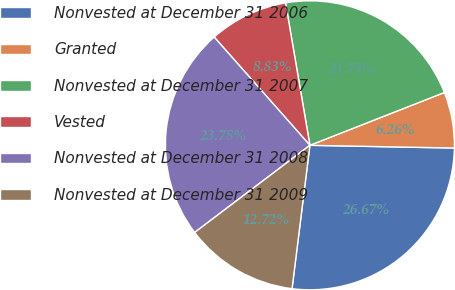<chart> <loc_0><loc_0><loc_500><loc_500><pie_chart><fcel>Nonvested at December 31 2006<fcel>Granted<fcel>Nonvested at December 31 2007<fcel>Vested<fcel>Nonvested at December 31 2008<fcel>Nonvested at December 31 2009<nl><fcel>26.67%<fcel>6.26%<fcel>21.74%<fcel>8.83%<fcel>23.78%<fcel>12.72%<nl></chart> 